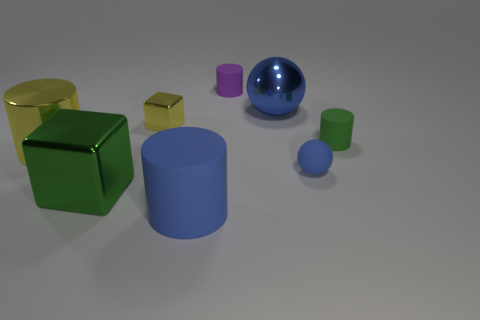Does the tiny sphere have the same material as the blue sphere behind the tiny rubber sphere?
Provide a short and direct response. No. Is there any other thing that is the same color as the big ball?
Your response must be concise. Yes. Is there a matte thing in front of the blue sphere that is in front of the big metallic thing that is behind the yellow metal cube?
Your answer should be compact. Yes. What is the color of the big shiny sphere?
Offer a very short reply. Blue. Are there any tiny matte cylinders behind the green rubber object?
Provide a short and direct response. Yes. There is a green matte thing; is it the same shape as the yellow shiny thing right of the big green shiny cube?
Offer a very short reply. No. The small object in front of the thing that is left of the green object that is on the left side of the tiny blue matte object is what color?
Keep it short and to the point. Blue. The big yellow object that is on the left side of the large blue thing that is behind the large cube is what shape?
Make the answer very short. Cylinder. Is the number of yellow objects that are in front of the tiny blue matte ball greater than the number of tiny yellow objects?
Provide a succinct answer. No. There is a green object left of the blue metal sphere; does it have the same shape as the tiny blue rubber object?
Make the answer very short. No. 